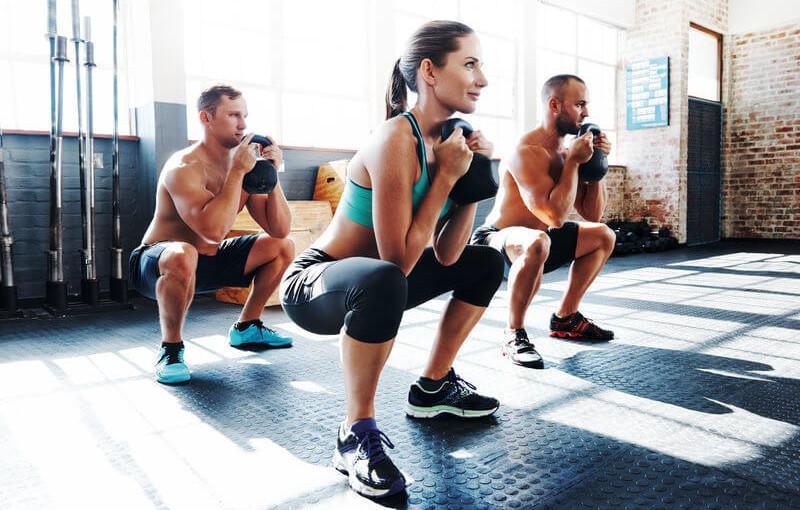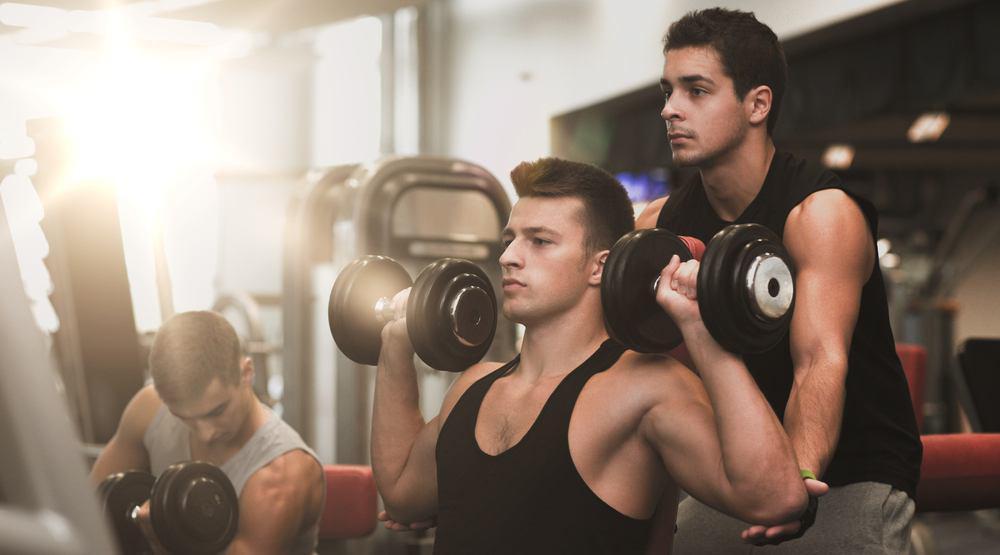The first image is the image on the left, the second image is the image on the right. Evaluate the accuracy of this statement regarding the images: "The left and right image contains the same number of people working out.". Is it true? Answer yes or no. Yes. The first image is the image on the left, the second image is the image on the right. Given the left and right images, does the statement "A person is holding a weight above their head." hold true? Answer yes or no. No. 